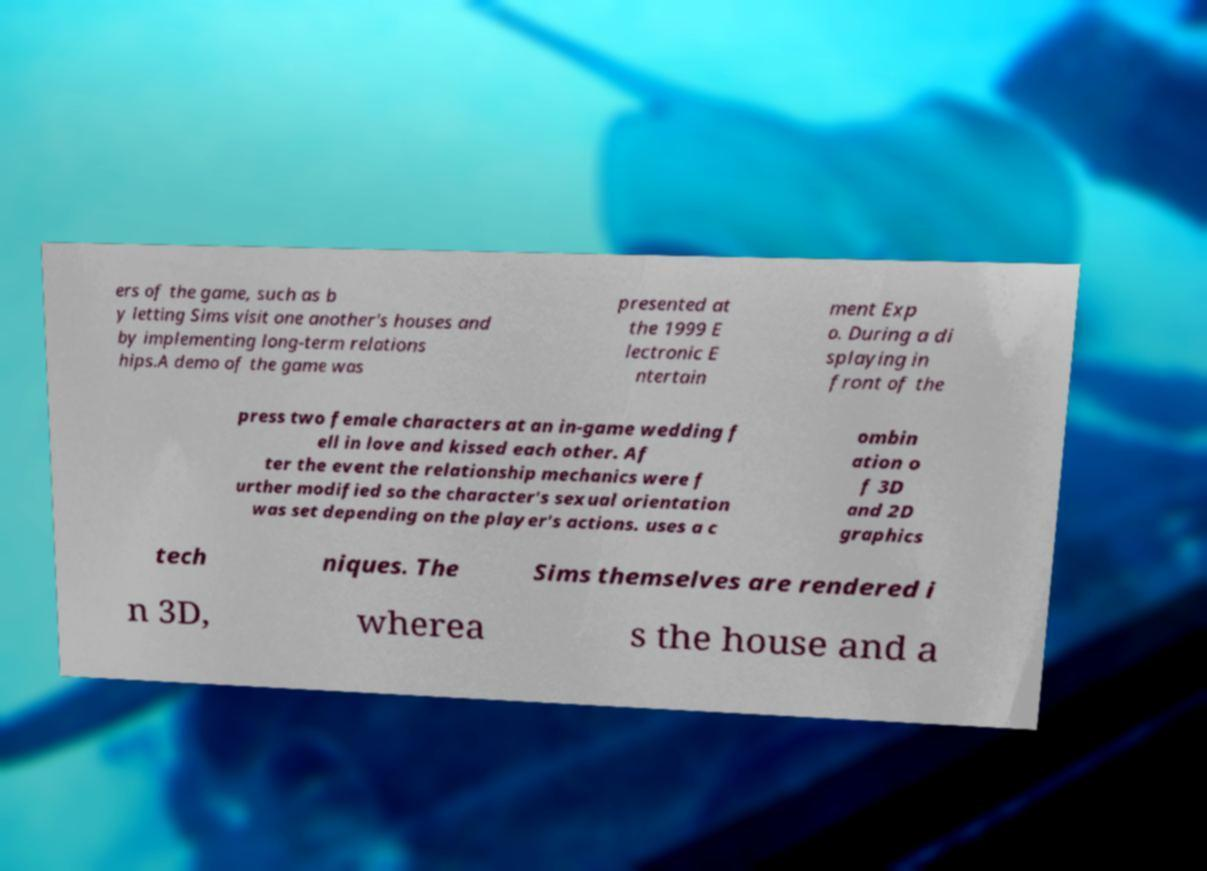Can you accurately transcribe the text from the provided image for me? ers of the game, such as b y letting Sims visit one another's houses and by implementing long-term relations hips.A demo of the game was presented at the 1999 E lectronic E ntertain ment Exp o. During a di splaying in front of the press two female characters at an in-game wedding f ell in love and kissed each other. Af ter the event the relationship mechanics were f urther modified so the character's sexual orientation was set depending on the player's actions. uses a c ombin ation o f 3D and 2D graphics tech niques. The Sims themselves are rendered i n 3D, wherea s the house and a 